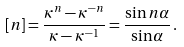<formula> <loc_0><loc_0><loc_500><loc_500>[ n ] = \frac { \kappa ^ { n } - \kappa ^ { - n } } { \kappa - \kappa ^ { - 1 } } = \frac { \sin n \alpha } { \sin \alpha } \, .</formula> 